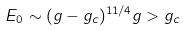<formula> <loc_0><loc_0><loc_500><loc_500>E _ { 0 } \sim ( g - g _ { c } ) ^ { 1 1 / 4 } g > g _ { c }</formula> 